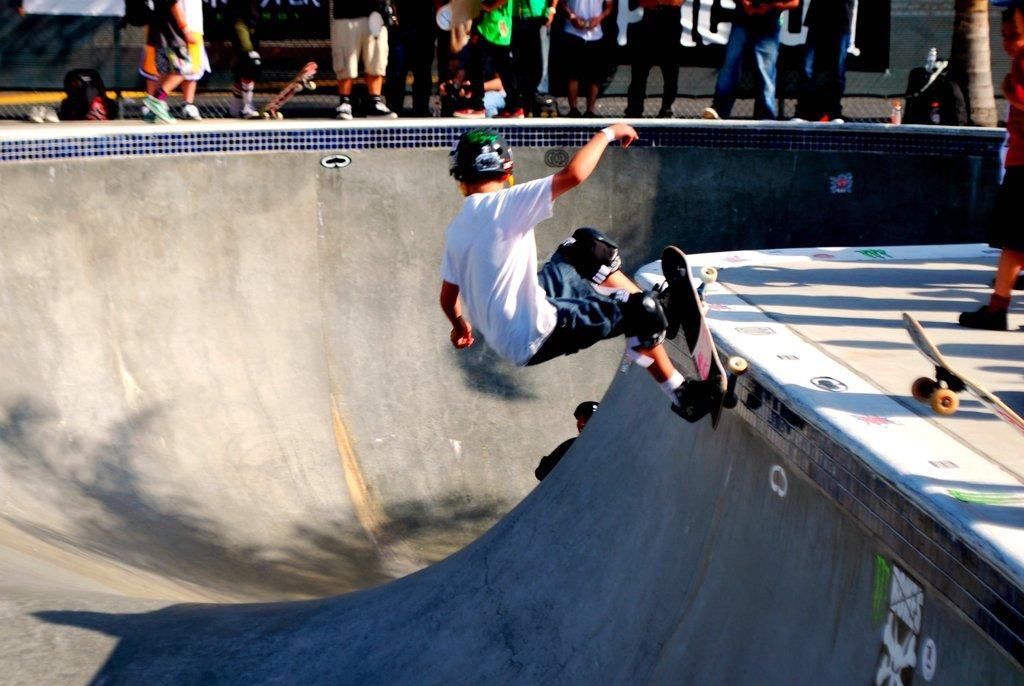What activity is the person in the image engaged in? The person in the image is doing skating. What tool is the person using for skating? The person is using a skateboard. How many people are standing on the floor in the image? There are multiple people standing on the floor in the image. What type of dirt can be seen in the image? There is no dirt visible in the image. Is the skating taking place in a wilderness setting? The provided facts do not mention the setting or location of the skating, so it cannot be determined if it is in a wilderness setting. 